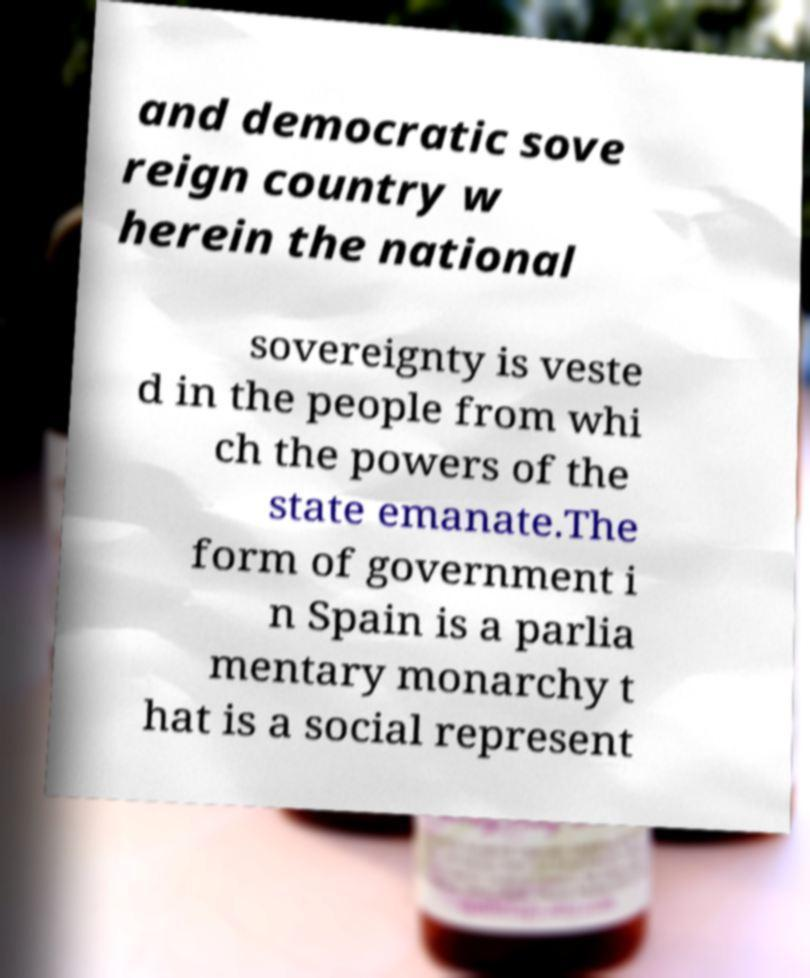Please read and relay the text visible in this image. What does it say? and democratic sove reign country w herein the national sovereignty is veste d in the people from whi ch the powers of the state emanate.The form of government i n Spain is a parlia mentary monarchy t hat is a social represent 